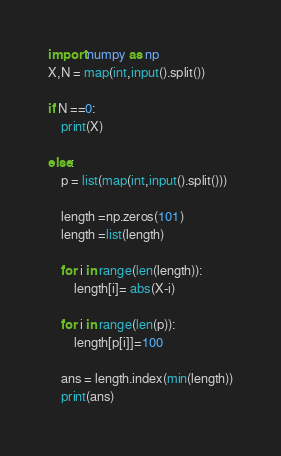<code> <loc_0><loc_0><loc_500><loc_500><_Python_>import numpy as np
X,N = map(int,input().split())

if N ==0:
    print(X)

else:
    p = list(map(int,input().split()))

    length =np.zeros(101)
    length =list(length)

    for i in range(len(length)):
        length[i]= abs(X-i)

    for i in range(len(p)):
        length[p[i]]=100

    ans = length.index(min(length))
    print(ans)
</code> 